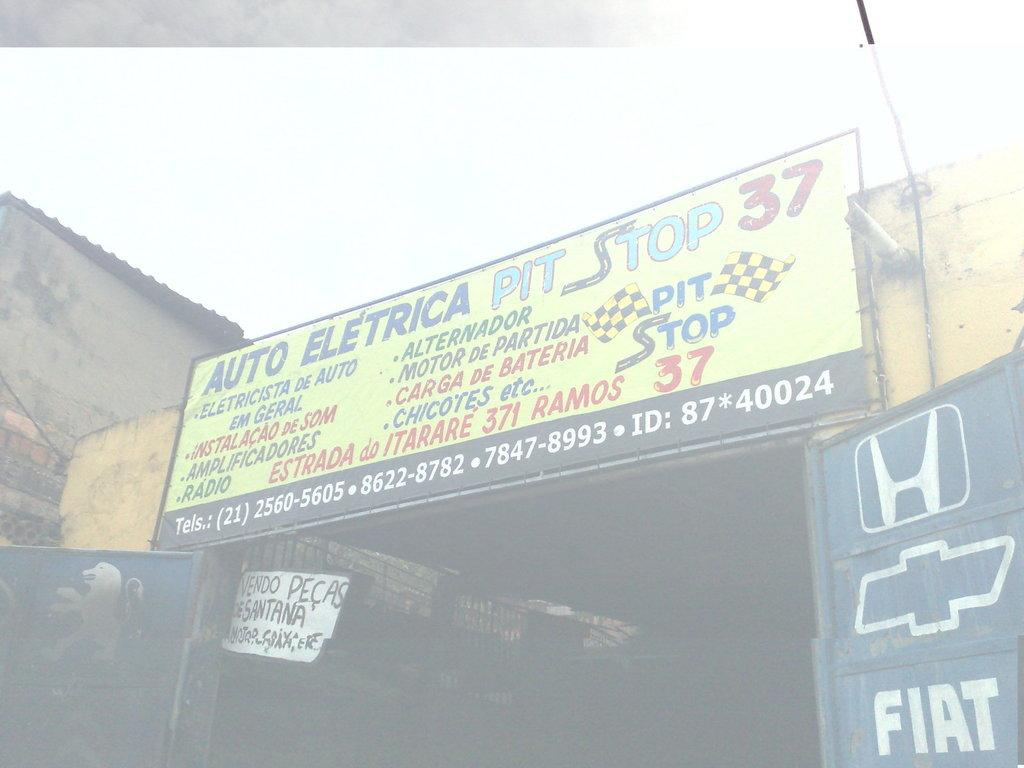<image>
Give a short and clear explanation of the subsequent image. a billboard with a stop 37 name at the top 